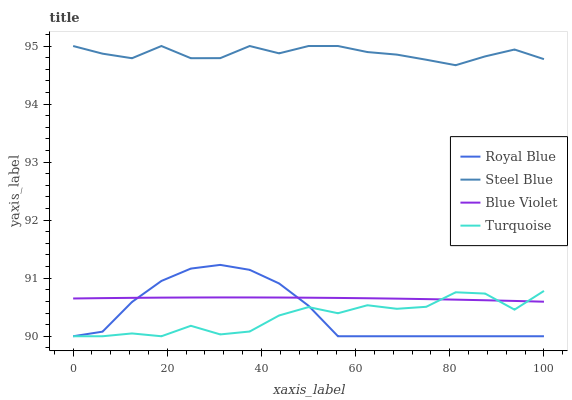Does Turquoise have the minimum area under the curve?
Answer yes or no. Yes. Does Steel Blue have the maximum area under the curve?
Answer yes or no. Yes. Does Steel Blue have the minimum area under the curve?
Answer yes or no. No. Does Turquoise have the maximum area under the curve?
Answer yes or no. No. Is Blue Violet the smoothest?
Answer yes or no. Yes. Is Turquoise the roughest?
Answer yes or no. Yes. Is Steel Blue the smoothest?
Answer yes or no. No. Is Steel Blue the roughest?
Answer yes or no. No. Does Steel Blue have the lowest value?
Answer yes or no. No. Does Steel Blue have the highest value?
Answer yes or no. Yes. Does Turquoise have the highest value?
Answer yes or no. No. Is Turquoise less than Steel Blue?
Answer yes or no. Yes. Is Steel Blue greater than Turquoise?
Answer yes or no. Yes. Does Turquoise intersect Blue Violet?
Answer yes or no. Yes. Is Turquoise less than Blue Violet?
Answer yes or no. No. Is Turquoise greater than Blue Violet?
Answer yes or no. No. Does Turquoise intersect Steel Blue?
Answer yes or no. No. 